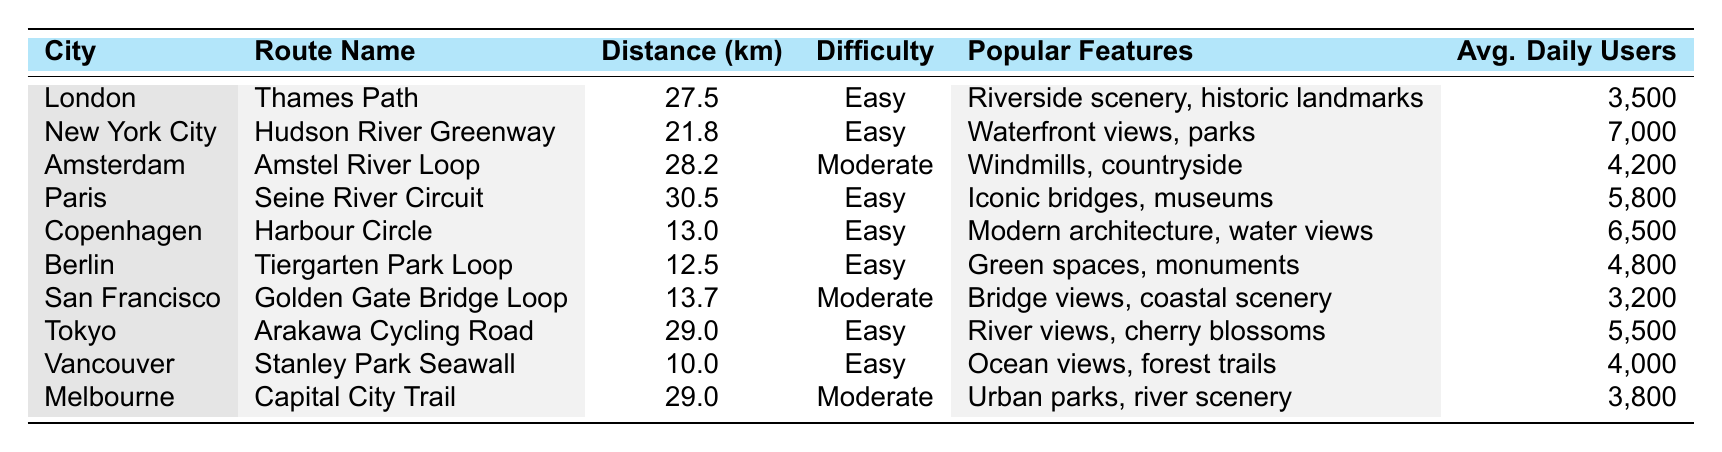What's the shortest cycling route listed in the table? The shortest route is found by comparing the distances of all routes. The distances are as follows: Thames Path (27.5 km), Hudson River Greenway (21.8 km), Amstel River Loop (28.2 km), Seine River Circuit (30.5 km), Harbour Circle (13.0 km), Tiergarten Park Loop (12.5 km), Golden Gate Bridge Loop (13.7 km), Arakawa Cycling Road (29.0 km), Stanley Park Seawall (10.0 km), and Capital City Trail (29.0 km). The shortest distance is 10.0 km for the Stanley Park Seawall.
Answer: 10.0 km Which route has the highest average daily users? We compare the average daily users for each route: Thames Path (3,500), Hudson River Greenway (7,000), Amstel River Loop (4,200), Seine River Circuit (5,800), Harbour Circle (6,500), Tiergarten Park Loop (4,800), Golden Gate Bridge Loop (3,200), Arakawa Cycling Road (5,500), Stanley Park Seawall (4,000), and Capital City Trail (3,800). The highest number is 7,000 for the Hudson River Greenway.
Answer: 7,000 How many routes have a difficulty rating of "Easy"? We scan the table for routes labeled "Easy." They are: Thames Path, Hudson River Greenway, Seine River Circuit, Harbour Circle, Tiergarten Park Loop, Arakawa Cycling Road, and Stanley Park Seawall. Counting these gives us 7 routes.
Answer: 7 What is the average distance of all cycling routes in the table? To find the average distance, we sum the distances: 27.5 + 21.8 + 28.2 + 30.5 + 13.0 + 12.5 + 13.7 + 29.0 + 10.0 + 29.0 =  275.7 km. There are 10 routes, so we calculate the average as 275.7 / 10 = 27.57 km.
Answer: 27.57 km Are there any routes in the table that have features related to nature (like trees or plants)? We check the features of each route for nature-related mentions. The Tiergarten Park Loop mentions green spaces, Arakawa Cycling Road mentions cherry blossoms, and Stanley Park Seawall mentions forest trails. Therefore, there are routes with nature-related features.
Answer: Yes Which city has a cycling route that is the longest, and what is the route name? We examine the distances to find the longest route. The distances are as follows: Thames Path (27.5 km), Hudson River Greenway (21.8 km), Amstel River Loop (28.2 km), Seine River Circuit (30.5 km), Harbour Circle (13.0 km), Tiergarten Park Loop (12.5 km), Golden Gate Bridge Loop (13.7 km), Arakawa Cycling Road (29.0 km), Stanley Park Seawall (10.0 km), Capital City Trail (29.0 km). The longest route is the Seine River Circuit at 30.5 km, located in Paris.
Answer: Paris, Seine River Circuit What is the total number of average daily users for all routes combined? We sum the average daily users: 3,500 + 7,000 + 4,200 + 5,800 + 6,500 + 4,800 + 3,200 + 5,500 + 4,000 + 3,800 = 43,300 users total.
Answer: 43,300 Which two routes have the same distance of 29.0 km? We look through the distance values to find matches. Amstel River Loop and Capital City Trail both measure 29.0 km.
Answer: Amstel River Loop, Capital City Trail How many routes in the table have a "Moderate" difficulty level? We check the difficulty ratings for the routes. Only the Amstel River Loop, Golden Gate Bridge Loop, and Capital City Trail are rated as "Moderate." Thus, there are 3 routes with a moderate difficulty level.
Answer: 3 Does the Harbour Circle route have any features related to historical elements? We look at the features listed for the Harbour Circle, which are modern architecture and water views. There are no historical features mentioned.
Answer: No 